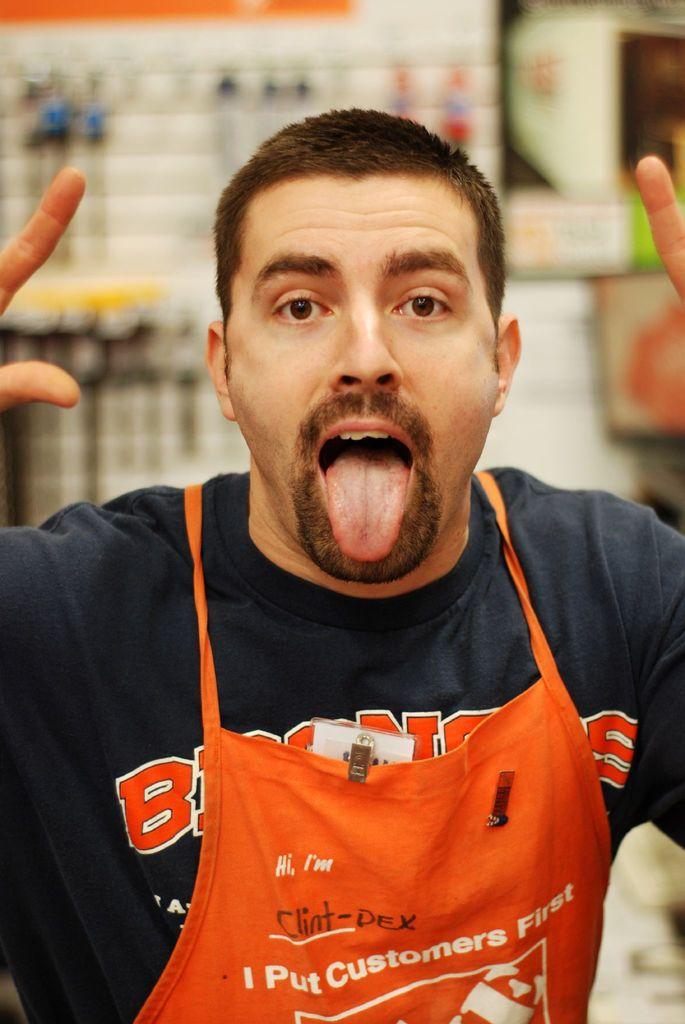Who does this man put first?
Give a very brief answer. Customers. What is this man's name?
Keep it short and to the point. Clint-dex. 